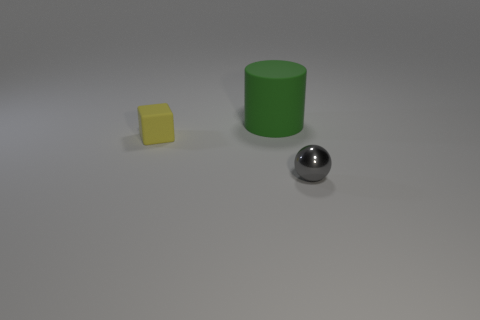How many objects are small objects behind the tiny metal sphere or tiny objects?
Make the answer very short. 2. Does the tiny object on the right side of the block have the same color as the rubber object that is behind the yellow object?
Offer a very short reply. No. What size is the gray thing?
Make the answer very short. Small. What number of small things are green matte things or gray things?
Ensure brevity in your answer.  1. The shiny thing that is the same size as the yellow cube is what color?
Your answer should be compact. Gray. What number of other objects are there of the same shape as the yellow matte thing?
Keep it short and to the point. 0. Is there a green cylinder that has the same material as the large green thing?
Make the answer very short. No. Is the material of the tiny thing right of the tiny yellow rubber cube the same as the tiny object behind the shiny object?
Offer a terse response. No. How many green matte cylinders are there?
Make the answer very short. 1. What shape is the small object on the right side of the large cylinder?
Your answer should be compact. Sphere. 